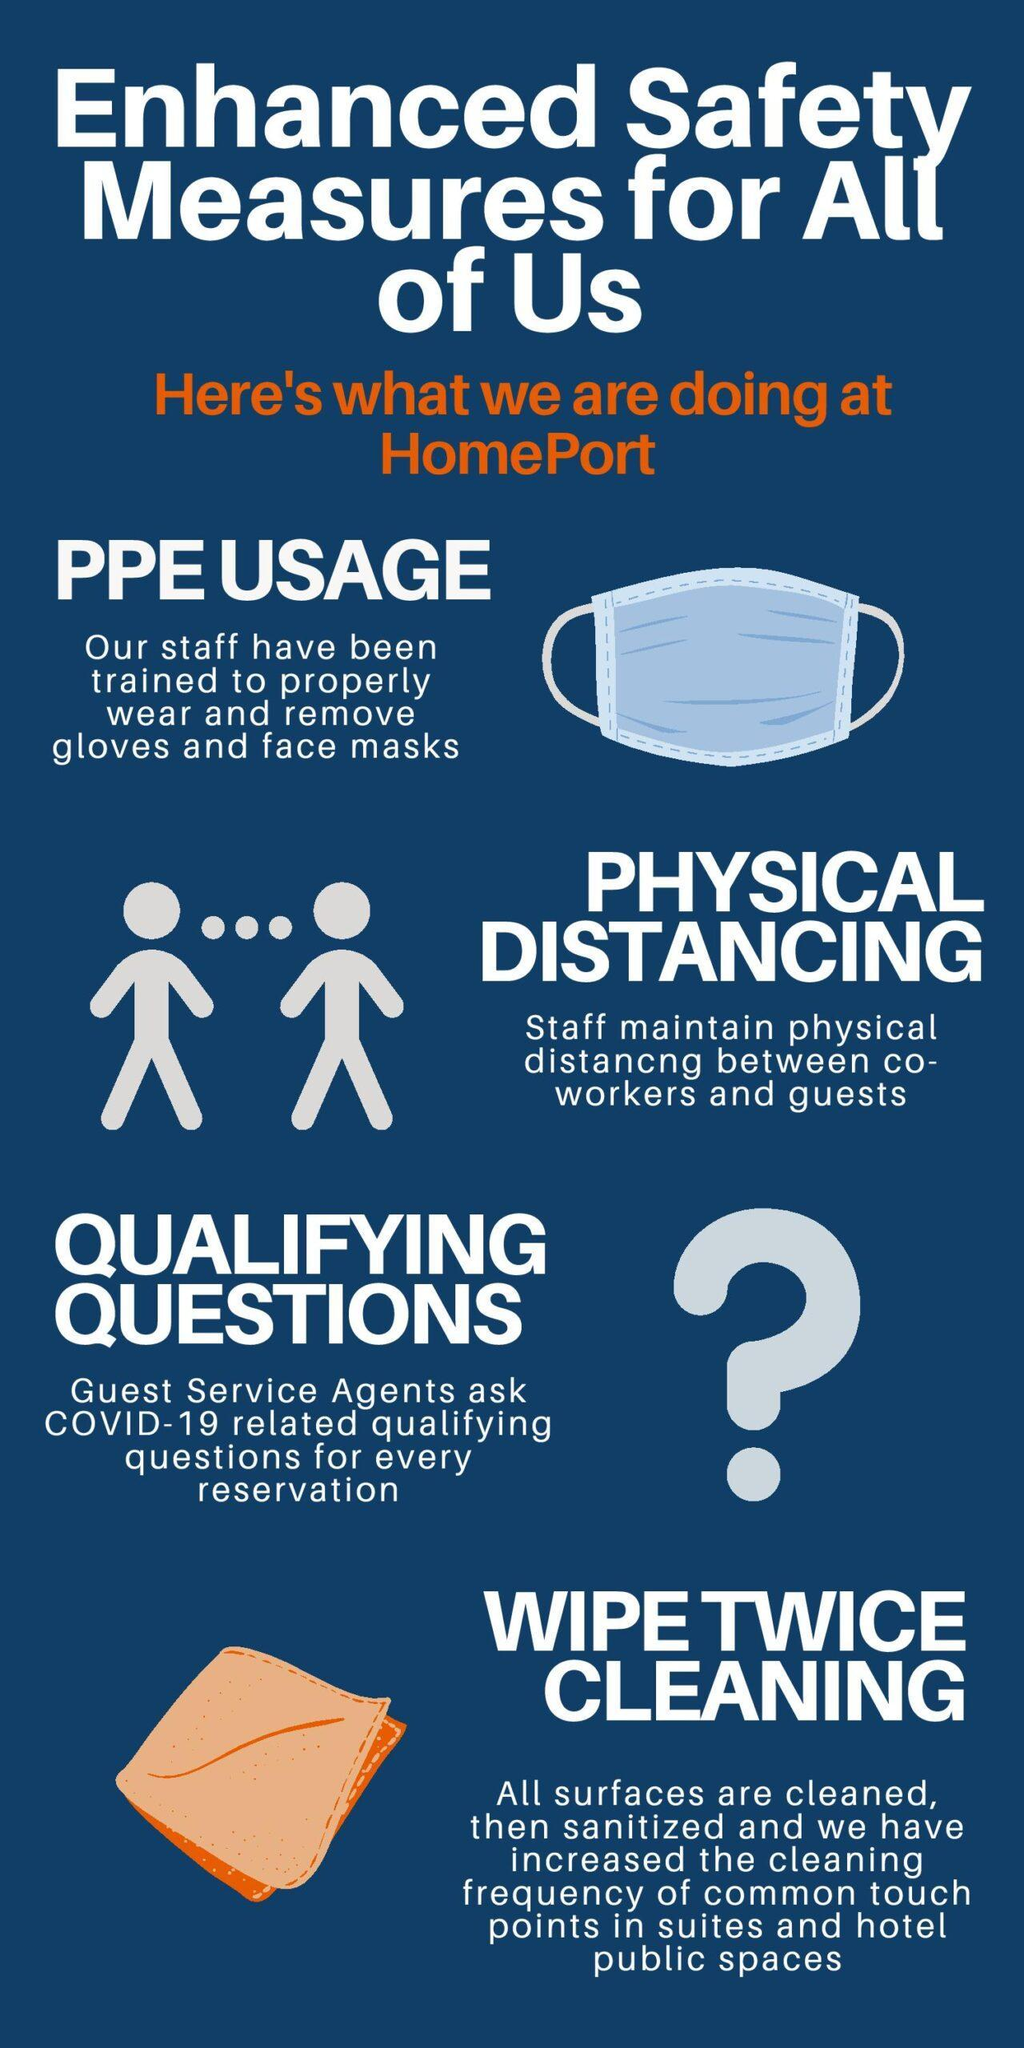What are the safety measures taken at the homeport other than the PPE usage & physical distancing?
Answer the question with a short phrase. QUALIFYING QUESTIONS, WIPE TWICE CLEANING 